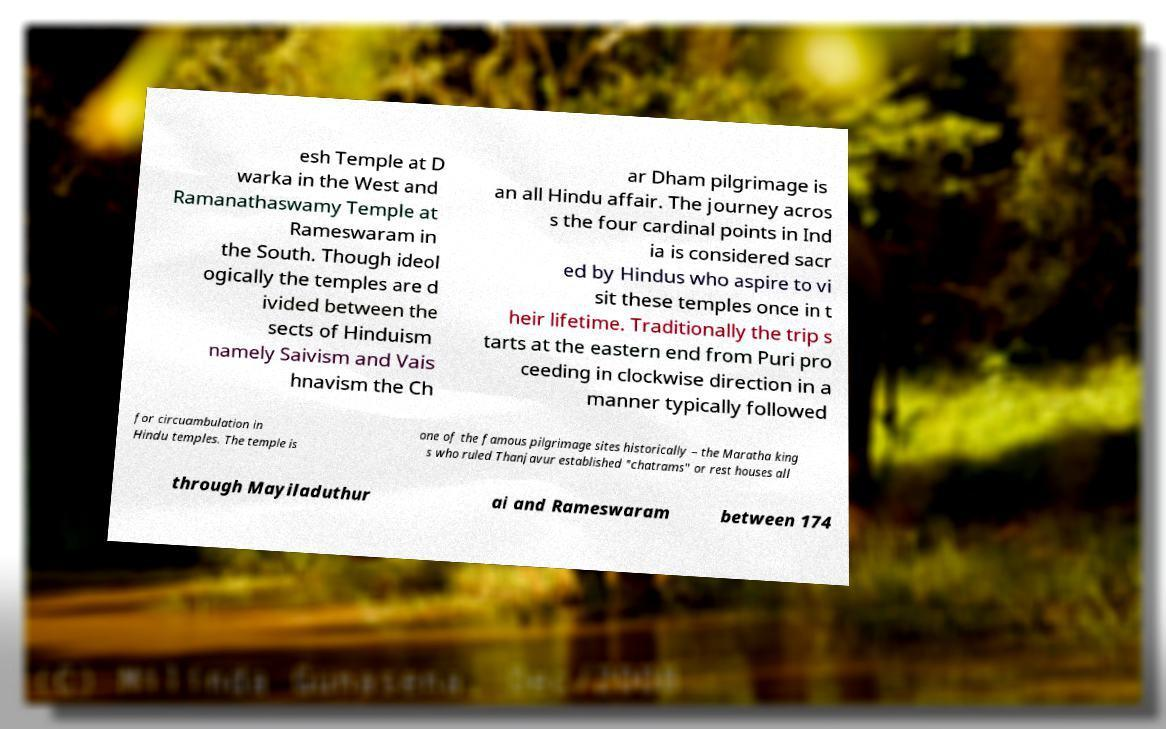Please read and relay the text visible in this image. What does it say? esh Temple at D warka in the West and Ramanathaswamy Temple at Rameswaram in the South. Though ideol ogically the temples are d ivided between the sects of Hinduism namely Saivism and Vais hnavism the Ch ar Dham pilgrimage is an all Hindu affair. The journey acros s the four cardinal points in Ind ia is considered sacr ed by Hindus who aspire to vi sit these temples once in t heir lifetime. Traditionally the trip s tarts at the eastern end from Puri pro ceeding in clockwise direction in a manner typically followed for circuambulation in Hindu temples. The temple is one of the famous pilgrimage sites historically – the Maratha king s who ruled Thanjavur established "chatrams" or rest houses all through Mayiladuthur ai and Rameswaram between 174 